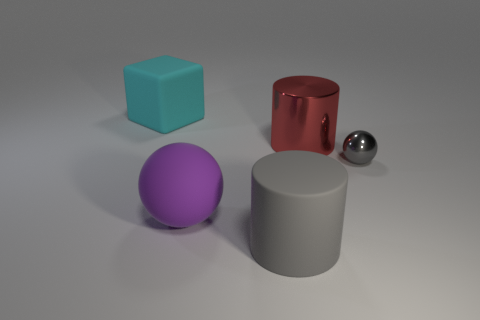Is there anything else that has the same size as the gray shiny thing?
Keep it short and to the point. No. Are there fewer metallic cylinders left of the big red metal cylinder than rubber spheres?
Give a very brief answer. Yes. Is the shape of the gray rubber object the same as the red thing?
Provide a succinct answer. Yes. What color is the other object that is the same shape as the big shiny thing?
Ensure brevity in your answer.  Gray. How many other large matte spheres have the same color as the big sphere?
Make the answer very short. 0. What number of objects are large cylinders that are behind the small gray object or big gray rubber objects?
Offer a terse response. 2. There is a gray thing to the right of the gray cylinder; what size is it?
Keep it short and to the point. Small. Are there fewer big cyan metallic things than metal objects?
Your answer should be compact. Yes. Is the material of the gray thing in front of the gray shiny thing the same as the sphere that is on the left side of the large red metallic cylinder?
Offer a terse response. Yes. There is a metallic object in front of the cylinder behind the gray object left of the tiny thing; what shape is it?
Your response must be concise. Sphere. 